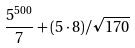<formula> <loc_0><loc_0><loc_500><loc_500>\frac { 5 ^ { 5 0 0 } } { 7 } + ( 5 \cdot 8 ) / \sqrt { 1 7 0 }</formula> 